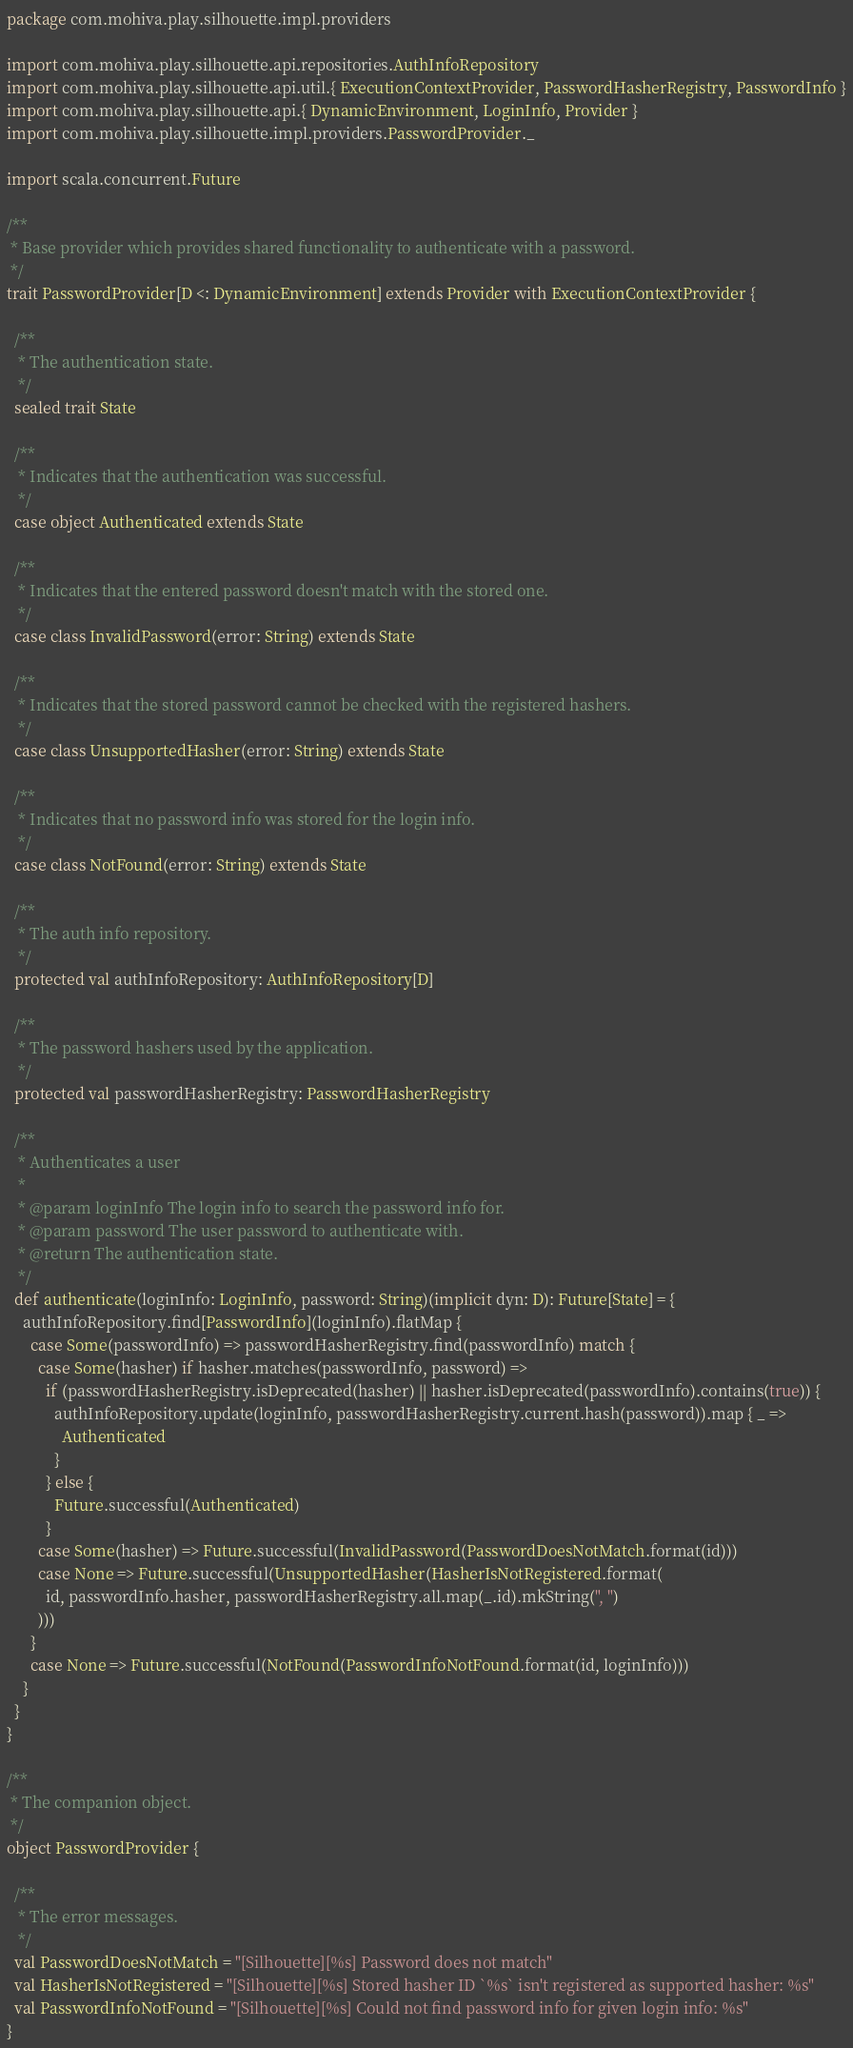Convert code to text. <code><loc_0><loc_0><loc_500><loc_500><_Scala_>package com.mohiva.play.silhouette.impl.providers

import com.mohiva.play.silhouette.api.repositories.AuthInfoRepository
import com.mohiva.play.silhouette.api.util.{ ExecutionContextProvider, PasswordHasherRegistry, PasswordInfo }
import com.mohiva.play.silhouette.api.{ DynamicEnvironment, LoginInfo, Provider }
import com.mohiva.play.silhouette.impl.providers.PasswordProvider._

import scala.concurrent.Future

/**
 * Base provider which provides shared functionality to authenticate with a password.
 */
trait PasswordProvider[D <: DynamicEnvironment] extends Provider with ExecutionContextProvider {

  /**
   * The authentication state.
   */
  sealed trait State

  /**
   * Indicates that the authentication was successful.
   */
  case object Authenticated extends State

  /**
   * Indicates that the entered password doesn't match with the stored one.
   */
  case class InvalidPassword(error: String) extends State

  /**
   * Indicates that the stored password cannot be checked with the registered hashers.
   */
  case class UnsupportedHasher(error: String) extends State

  /**
   * Indicates that no password info was stored for the login info.
   */
  case class NotFound(error: String) extends State

  /**
   * The auth info repository.
   */
  protected val authInfoRepository: AuthInfoRepository[D]

  /**
   * The password hashers used by the application.
   */
  protected val passwordHasherRegistry: PasswordHasherRegistry

  /**
   * Authenticates a user
   *
   * @param loginInfo The login info to search the password info for.
   * @param password The user password to authenticate with.
   * @return The authentication state.
   */
  def authenticate(loginInfo: LoginInfo, password: String)(implicit dyn: D): Future[State] = {
    authInfoRepository.find[PasswordInfo](loginInfo).flatMap {
      case Some(passwordInfo) => passwordHasherRegistry.find(passwordInfo) match {
        case Some(hasher) if hasher.matches(passwordInfo, password) =>
          if (passwordHasherRegistry.isDeprecated(hasher) || hasher.isDeprecated(passwordInfo).contains(true)) {
            authInfoRepository.update(loginInfo, passwordHasherRegistry.current.hash(password)).map { _ =>
              Authenticated
            }
          } else {
            Future.successful(Authenticated)
          }
        case Some(hasher) => Future.successful(InvalidPassword(PasswordDoesNotMatch.format(id)))
        case None => Future.successful(UnsupportedHasher(HasherIsNotRegistered.format(
          id, passwordInfo.hasher, passwordHasherRegistry.all.map(_.id).mkString(", ")
        )))
      }
      case None => Future.successful(NotFound(PasswordInfoNotFound.format(id, loginInfo)))
    }
  }
}

/**
 * The companion object.
 */
object PasswordProvider {

  /**
   * The error messages.
   */
  val PasswordDoesNotMatch = "[Silhouette][%s] Password does not match"
  val HasherIsNotRegistered = "[Silhouette][%s] Stored hasher ID `%s` isn't registered as supported hasher: %s"
  val PasswordInfoNotFound = "[Silhouette][%s] Could not find password info for given login info: %s"
}

</code> 